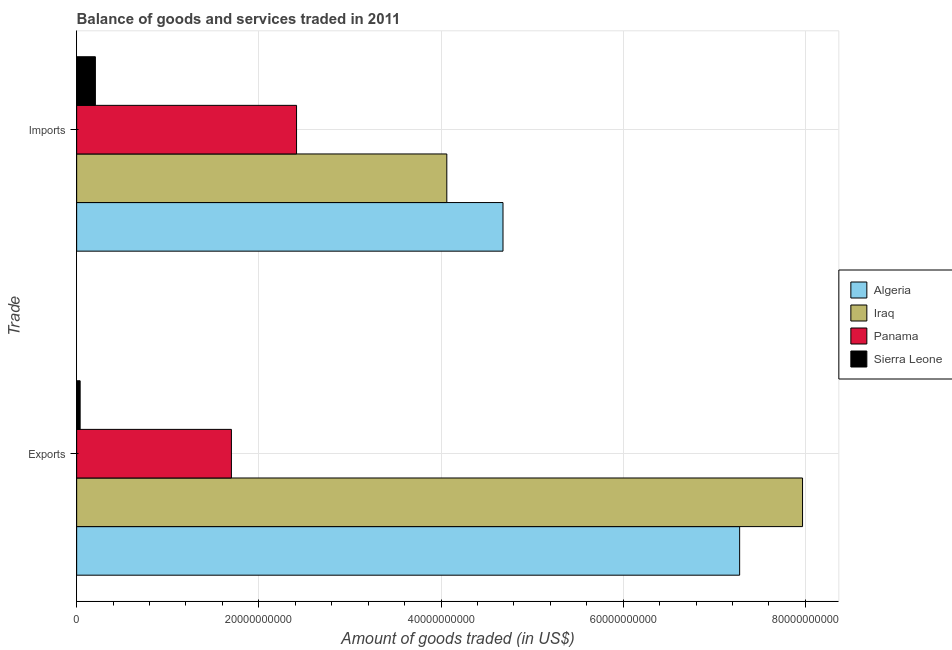How many different coloured bars are there?
Ensure brevity in your answer.  4. Are the number of bars on each tick of the Y-axis equal?
Give a very brief answer. Yes. How many bars are there on the 2nd tick from the top?
Give a very brief answer. 4. How many bars are there on the 2nd tick from the bottom?
Offer a terse response. 4. What is the label of the 1st group of bars from the top?
Offer a very short reply. Imports. What is the amount of goods exported in Algeria?
Ensure brevity in your answer.  7.28e+1. Across all countries, what is the maximum amount of goods imported?
Your response must be concise. 4.68e+1. Across all countries, what is the minimum amount of goods exported?
Keep it short and to the point. 3.82e+08. In which country was the amount of goods imported maximum?
Your answer should be compact. Algeria. In which country was the amount of goods imported minimum?
Provide a succinct answer. Sierra Leone. What is the total amount of goods exported in the graph?
Your response must be concise. 1.70e+11. What is the difference between the amount of goods exported in Algeria and that in Sierra Leone?
Your answer should be compact. 7.24e+1. What is the difference between the amount of goods exported in Iraq and the amount of goods imported in Panama?
Offer a very short reply. 5.55e+1. What is the average amount of goods exported per country?
Ensure brevity in your answer.  4.25e+1. What is the difference between the amount of goods exported and amount of goods imported in Iraq?
Ensure brevity in your answer.  3.91e+1. In how many countries, is the amount of goods imported greater than 60000000000 US$?
Give a very brief answer. 0. What is the ratio of the amount of goods exported in Panama to that in Iraq?
Your answer should be compact. 0.21. What does the 4th bar from the top in Exports represents?
Offer a very short reply. Algeria. What does the 3rd bar from the bottom in Imports represents?
Provide a short and direct response. Panama. How many bars are there?
Make the answer very short. 8. Are all the bars in the graph horizontal?
Offer a terse response. Yes. What is the difference between two consecutive major ticks on the X-axis?
Provide a succinct answer. 2.00e+1. Does the graph contain any zero values?
Your response must be concise. No. What is the title of the graph?
Make the answer very short. Balance of goods and services traded in 2011. Does "Grenada" appear as one of the legend labels in the graph?
Ensure brevity in your answer.  No. What is the label or title of the X-axis?
Make the answer very short. Amount of goods traded (in US$). What is the label or title of the Y-axis?
Make the answer very short. Trade. What is the Amount of goods traded (in US$) of Algeria in Exports?
Provide a short and direct response. 7.28e+1. What is the Amount of goods traded (in US$) of Iraq in Exports?
Provide a succinct answer. 7.97e+1. What is the Amount of goods traded (in US$) in Panama in Exports?
Make the answer very short. 1.70e+1. What is the Amount of goods traded (in US$) of Sierra Leone in Exports?
Provide a short and direct response. 3.82e+08. What is the Amount of goods traded (in US$) in Algeria in Imports?
Offer a terse response. 4.68e+1. What is the Amount of goods traded (in US$) of Iraq in Imports?
Offer a very short reply. 4.06e+1. What is the Amount of goods traded (in US$) in Panama in Imports?
Your answer should be very brief. 2.41e+1. What is the Amount of goods traded (in US$) of Sierra Leone in Imports?
Your answer should be compact. 2.06e+09. Across all Trade, what is the maximum Amount of goods traded (in US$) in Algeria?
Give a very brief answer. 7.28e+1. Across all Trade, what is the maximum Amount of goods traded (in US$) of Iraq?
Your answer should be very brief. 7.97e+1. Across all Trade, what is the maximum Amount of goods traded (in US$) in Panama?
Offer a terse response. 2.41e+1. Across all Trade, what is the maximum Amount of goods traded (in US$) of Sierra Leone?
Provide a succinct answer. 2.06e+09. Across all Trade, what is the minimum Amount of goods traded (in US$) of Algeria?
Make the answer very short. 4.68e+1. Across all Trade, what is the minimum Amount of goods traded (in US$) of Iraq?
Your answer should be very brief. 4.06e+1. Across all Trade, what is the minimum Amount of goods traded (in US$) of Panama?
Offer a terse response. 1.70e+1. Across all Trade, what is the minimum Amount of goods traded (in US$) in Sierra Leone?
Provide a succinct answer. 3.82e+08. What is the total Amount of goods traded (in US$) of Algeria in the graph?
Offer a very short reply. 1.20e+11. What is the total Amount of goods traded (in US$) in Iraq in the graph?
Make the answer very short. 1.20e+11. What is the total Amount of goods traded (in US$) of Panama in the graph?
Give a very brief answer. 4.11e+1. What is the total Amount of goods traded (in US$) in Sierra Leone in the graph?
Your answer should be very brief. 2.44e+09. What is the difference between the Amount of goods traded (in US$) of Algeria in Exports and that in Imports?
Provide a short and direct response. 2.60e+1. What is the difference between the Amount of goods traded (in US$) in Iraq in Exports and that in Imports?
Your response must be concise. 3.91e+1. What is the difference between the Amount of goods traded (in US$) in Panama in Exports and that in Imports?
Ensure brevity in your answer.  -7.15e+09. What is the difference between the Amount of goods traded (in US$) of Sierra Leone in Exports and that in Imports?
Your answer should be very brief. -1.67e+09. What is the difference between the Amount of goods traded (in US$) in Algeria in Exports and the Amount of goods traded (in US$) in Iraq in Imports?
Offer a terse response. 3.21e+1. What is the difference between the Amount of goods traded (in US$) of Algeria in Exports and the Amount of goods traded (in US$) of Panama in Imports?
Your answer should be compact. 4.86e+1. What is the difference between the Amount of goods traded (in US$) in Algeria in Exports and the Amount of goods traded (in US$) in Sierra Leone in Imports?
Your response must be concise. 7.07e+1. What is the difference between the Amount of goods traded (in US$) in Iraq in Exports and the Amount of goods traded (in US$) in Panama in Imports?
Provide a succinct answer. 5.55e+1. What is the difference between the Amount of goods traded (in US$) in Iraq in Exports and the Amount of goods traded (in US$) in Sierra Leone in Imports?
Provide a succinct answer. 7.76e+1. What is the difference between the Amount of goods traded (in US$) in Panama in Exports and the Amount of goods traded (in US$) in Sierra Leone in Imports?
Offer a very short reply. 1.49e+1. What is the average Amount of goods traded (in US$) in Algeria per Trade?
Provide a succinct answer. 5.98e+1. What is the average Amount of goods traded (in US$) of Iraq per Trade?
Offer a very short reply. 6.02e+1. What is the average Amount of goods traded (in US$) in Panama per Trade?
Offer a terse response. 2.06e+1. What is the average Amount of goods traded (in US$) of Sierra Leone per Trade?
Give a very brief answer. 1.22e+09. What is the difference between the Amount of goods traded (in US$) of Algeria and Amount of goods traded (in US$) of Iraq in Exports?
Keep it short and to the point. -6.90e+09. What is the difference between the Amount of goods traded (in US$) of Algeria and Amount of goods traded (in US$) of Panama in Exports?
Offer a very short reply. 5.58e+1. What is the difference between the Amount of goods traded (in US$) in Algeria and Amount of goods traded (in US$) in Sierra Leone in Exports?
Offer a very short reply. 7.24e+1. What is the difference between the Amount of goods traded (in US$) in Iraq and Amount of goods traded (in US$) in Panama in Exports?
Make the answer very short. 6.27e+1. What is the difference between the Amount of goods traded (in US$) of Iraq and Amount of goods traded (in US$) of Sierra Leone in Exports?
Make the answer very short. 7.93e+1. What is the difference between the Amount of goods traded (in US$) in Panama and Amount of goods traded (in US$) in Sierra Leone in Exports?
Make the answer very short. 1.66e+1. What is the difference between the Amount of goods traded (in US$) in Algeria and Amount of goods traded (in US$) in Iraq in Imports?
Give a very brief answer. 6.17e+09. What is the difference between the Amount of goods traded (in US$) of Algeria and Amount of goods traded (in US$) of Panama in Imports?
Your answer should be very brief. 2.27e+1. What is the difference between the Amount of goods traded (in US$) in Algeria and Amount of goods traded (in US$) in Sierra Leone in Imports?
Ensure brevity in your answer.  4.47e+1. What is the difference between the Amount of goods traded (in US$) of Iraq and Amount of goods traded (in US$) of Panama in Imports?
Provide a short and direct response. 1.65e+1. What is the difference between the Amount of goods traded (in US$) in Iraq and Amount of goods traded (in US$) in Sierra Leone in Imports?
Make the answer very short. 3.86e+1. What is the difference between the Amount of goods traded (in US$) of Panama and Amount of goods traded (in US$) of Sierra Leone in Imports?
Offer a terse response. 2.21e+1. What is the ratio of the Amount of goods traded (in US$) of Algeria in Exports to that in Imports?
Offer a terse response. 1.56. What is the ratio of the Amount of goods traded (in US$) of Iraq in Exports to that in Imports?
Your response must be concise. 1.96. What is the ratio of the Amount of goods traded (in US$) of Panama in Exports to that in Imports?
Your response must be concise. 0.7. What is the ratio of the Amount of goods traded (in US$) of Sierra Leone in Exports to that in Imports?
Offer a very short reply. 0.19. What is the difference between the highest and the second highest Amount of goods traded (in US$) of Algeria?
Offer a terse response. 2.60e+1. What is the difference between the highest and the second highest Amount of goods traded (in US$) of Iraq?
Provide a succinct answer. 3.91e+1. What is the difference between the highest and the second highest Amount of goods traded (in US$) in Panama?
Make the answer very short. 7.15e+09. What is the difference between the highest and the second highest Amount of goods traded (in US$) of Sierra Leone?
Offer a terse response. 1.67e+09. What is the difference between the highest and the lowest Amount of goods traded (in US$) in Algeria?
Provide a short and direct response. 2.60e+1. What is the difference between the highest and the lowest Amount of goods traded (in US$) in Iraq?
Provide a short and direct response. 3.91e+1. What is the difference between the highest and the lowest Amount of goods traded (in US$) in Panama?
Your response must be concise. 7.15e+09. What is the difference between the highest and the lowest Amount of goods traded (in US$) in Sierra Leone?
Give a very brief answer. 1.67e+09. 